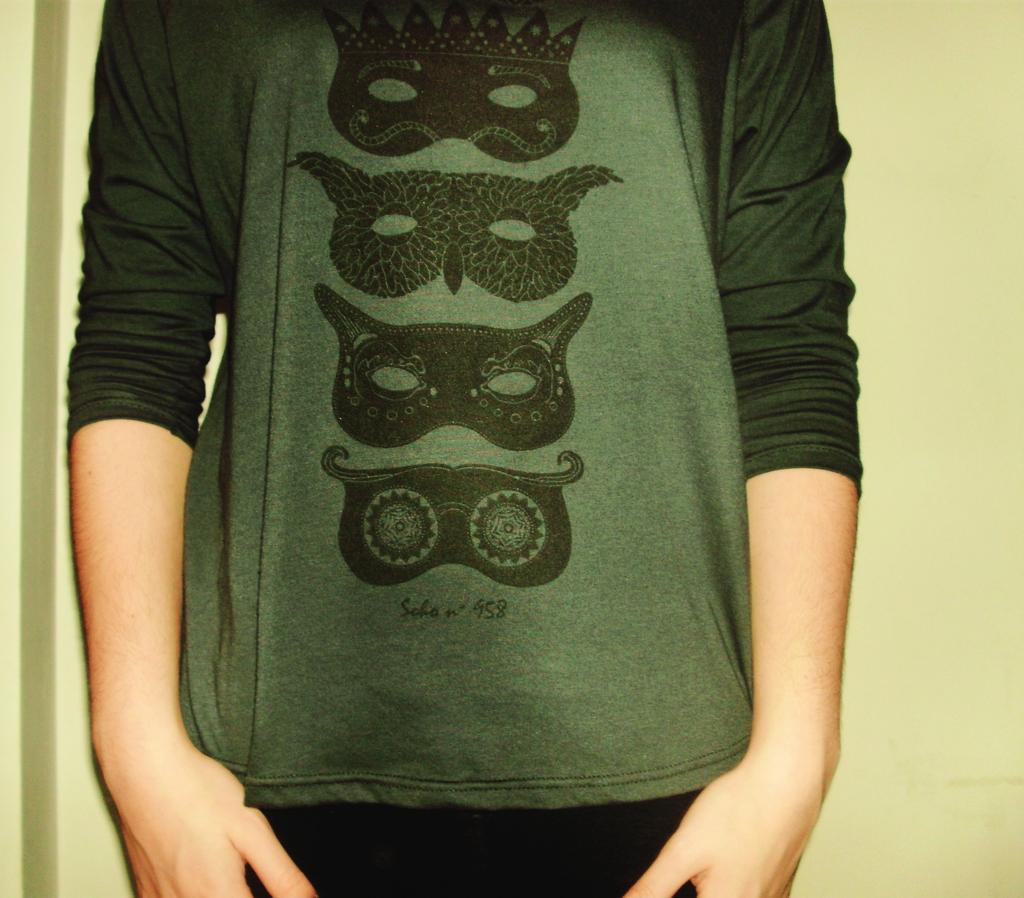What is the main subject of the image? There is a person in the image, but they are truncated. What can be seen in the background of the image? There is a wall in the background of the image, but it is also truncated. What type of space is the person exploring in the image? There is no indication of the person exploring any space in the image, as they are truncated and not fully visible. What is the plot of the story being depicted in the image? There is no story being depicted in the image, as it is a static photograph of a truncated person and wall. 